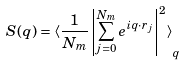<formula> <loc_0><loc_0><loc_500><loc_500>S ( q ) = \left < \frac { 1 } { N _ { m } } \left | \sum _ { j = 0 } ^ { N _ { m } } e ^ { i q \cdot r _ { j } } \right | ^ { 2 } \right > _ { q }</formula> 